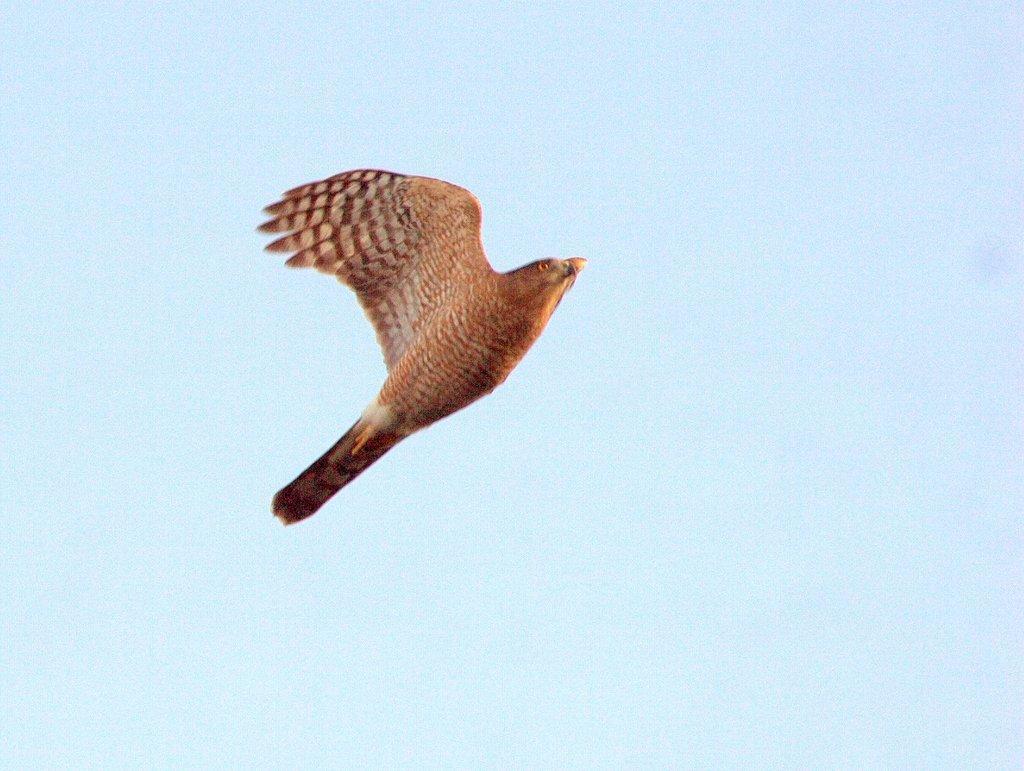In one or two sentences, can you explain what this image depicts? This image consists of a bird in brown color. In the background, there is sky. 